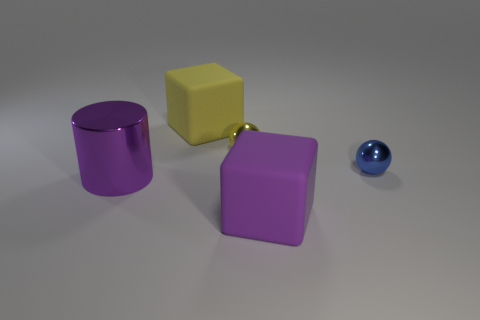Are there any other things that are the same shape as the large metallic thing?
Keep it short and to the point. No. Is the size of the ball to the left of the blue ball the same as the cylinder?
Your answer should be compact. No. The metallic sphere in front of the yellow sphere is what color?
Make the answer very short. Blue. How many small yellow objects are there?
Your response must be concise. 1. What is the shape of the purple thing that is made of the same material as the yellow ball?
Provide a short and direct response. Cylinder. Does the large object that is behind the purple shiny cylinder have the same color as the sphere on the right side of the big purple rubber thing?
Provide a short and direct response. No. Is the number of metal balls that are on the left side of the purple matte cube the same as the number of red matte cylinders?
Your answer should be very brief. No. There is a yellow rubber cube; what number of small blue metallic objects are in front of it?
Provide a short and direct response. 1. What size is the purple cylinder?
Make the answer very short. Large. The big thing that is made of the same material as the tiny blue sphere is what color?
Your response must be concise. Purple. 